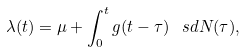Convert formula to latex. <formula><loc_0><loc_0><loc_500><loc_500>\lambda ( t ) = \mu + \int _ { 0 } ^ { t } g ( t - \tau ) \, \ s d N ( \tau ) ,</formula> 